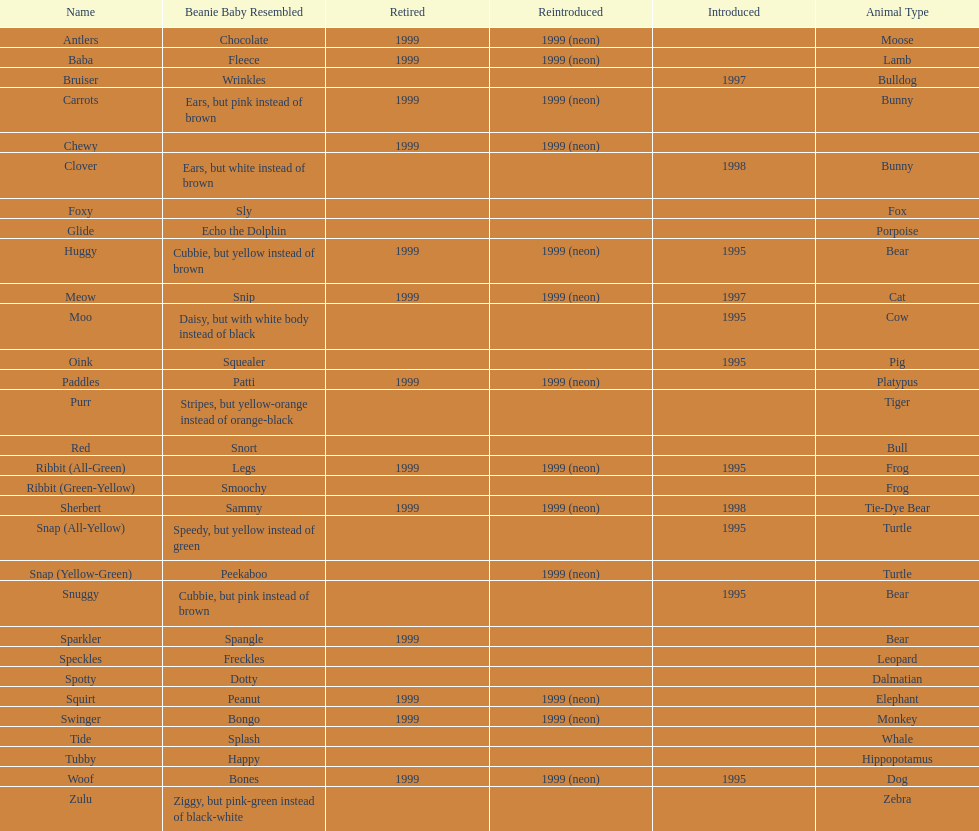What is the name of the pillow pal listed after clover? Foxy. 